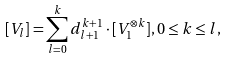Convert formula to latex. <formula><loc_0><loc_0><loc_500><loc_500>[ V _ { l } ] = { \sum _ { l = 0 } ^ { k } } \, d _ { l { + } 1 } ^ { k { + } 1 } \cdot [ V _ { 1 } ^ { \otimes k } ] , 0 \leq k \leq l ,</formula> 